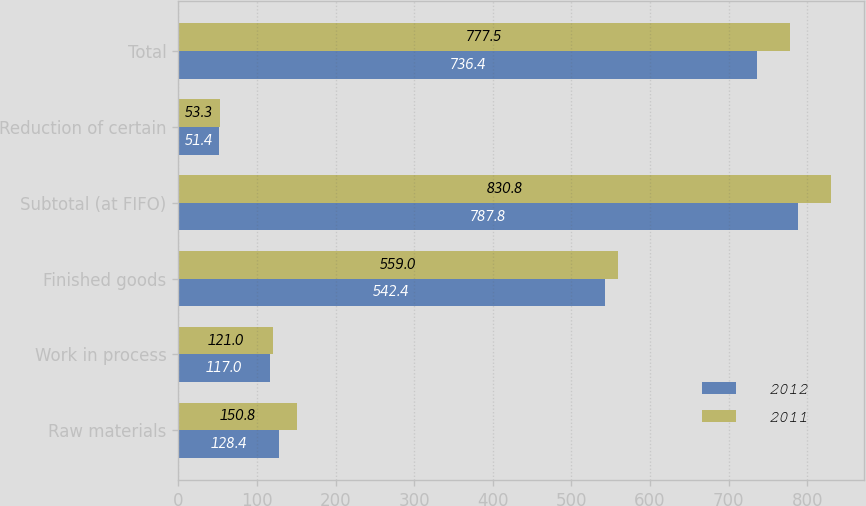Convert chart. <chart><loc_0><loc_0><loc_500><loc_500><stacked_bar_chart><ecel><fcel>Raw materials<fcel>Work in process<fcel>Finished goods<fcel>Subtotal (at FIFO)<fcel>Reduction of certain<fcel>Total<nl><fcel>2012<fcel>128.4<fcel>117<fcel>542.4<fcel>787.8<fcel>51.4<fcel>736.4<nl><fcel>2011<fcel>150.8<fcel>121<fcel>559<fcel>830.8<fcel>53.3<fcel>777.5<nl></chart> 